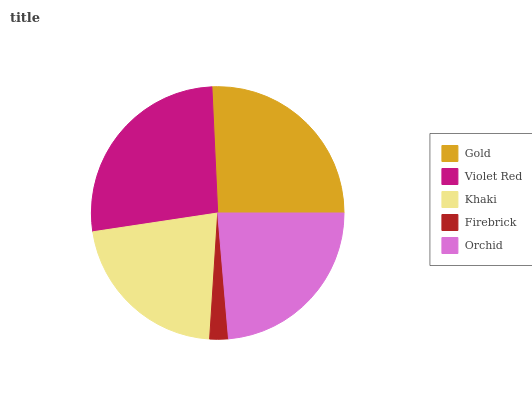Is Firebrick the minimum?
Answer yes or no. Yes. Is Violet Red the maximum?
Answer yes or no. Yes. Is Khaki the minimum?
Answer yes or no. No. Is Khaki the maximum?
Answer yes or no. No. Is Violet Red greater than Khaki?
Answer yes or no. Yes. Is Khaki less than Violet Red?
Answer yes or no. Yes. Is Khaki greater than Violet Red?
Answer yes or no. No. Is Violet Red less than Khaki?
Answer yes or no. No. Is Orchid the high median?
Answer yes or no. Yes. Is Orchid the low median?
Answer yes or no. Yes. Is Khaki the high median?
Answer yes or no. No. Is Gold the low median?
Answer yes or no. No. 